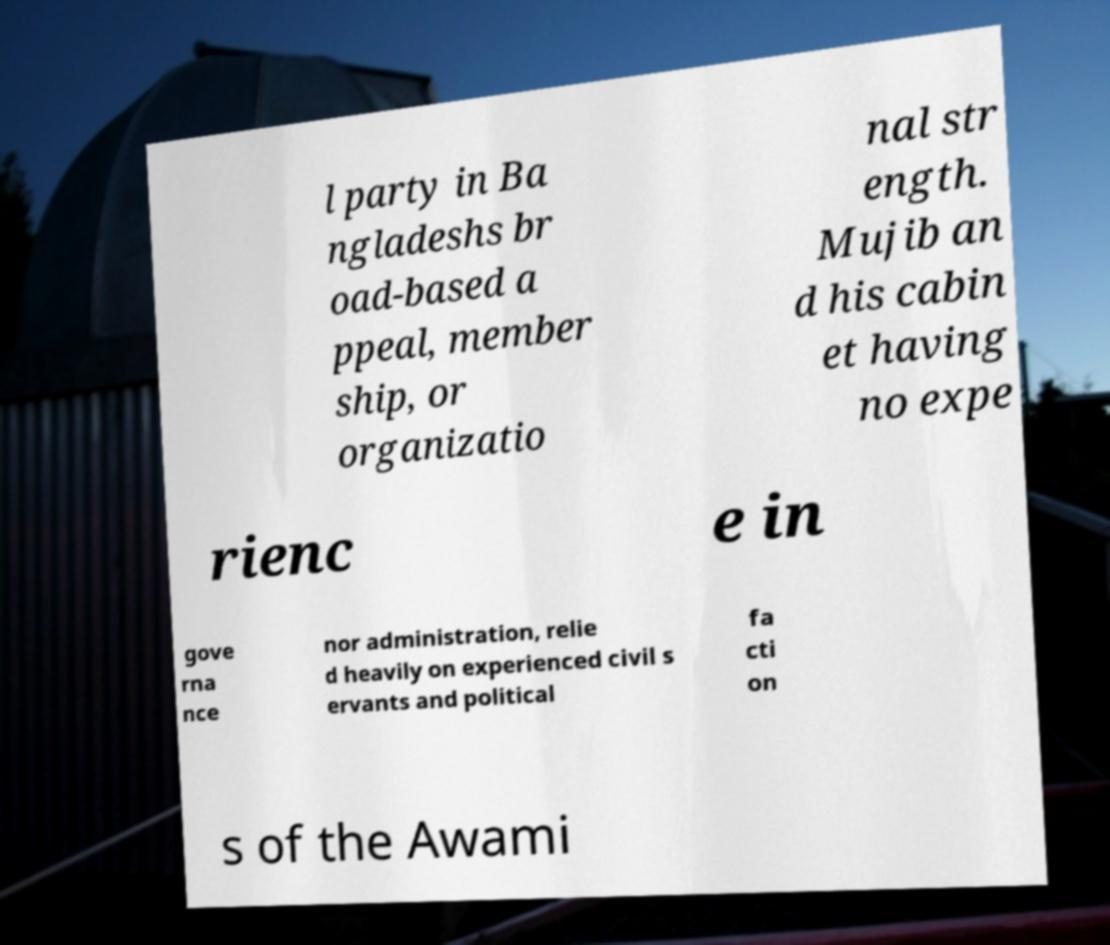For documentation purposes, I need the text within this image transcribed. Could you provide that? l party in Ba ngladeshs br oad-based a ppeal, member ship, or organizatio nal str ength. Mujib an d his cabin et having no expe rienc e in gove rna nce nor administration, relie d heavily on experienced civil s ervants and political fa cti on s of the Awami 